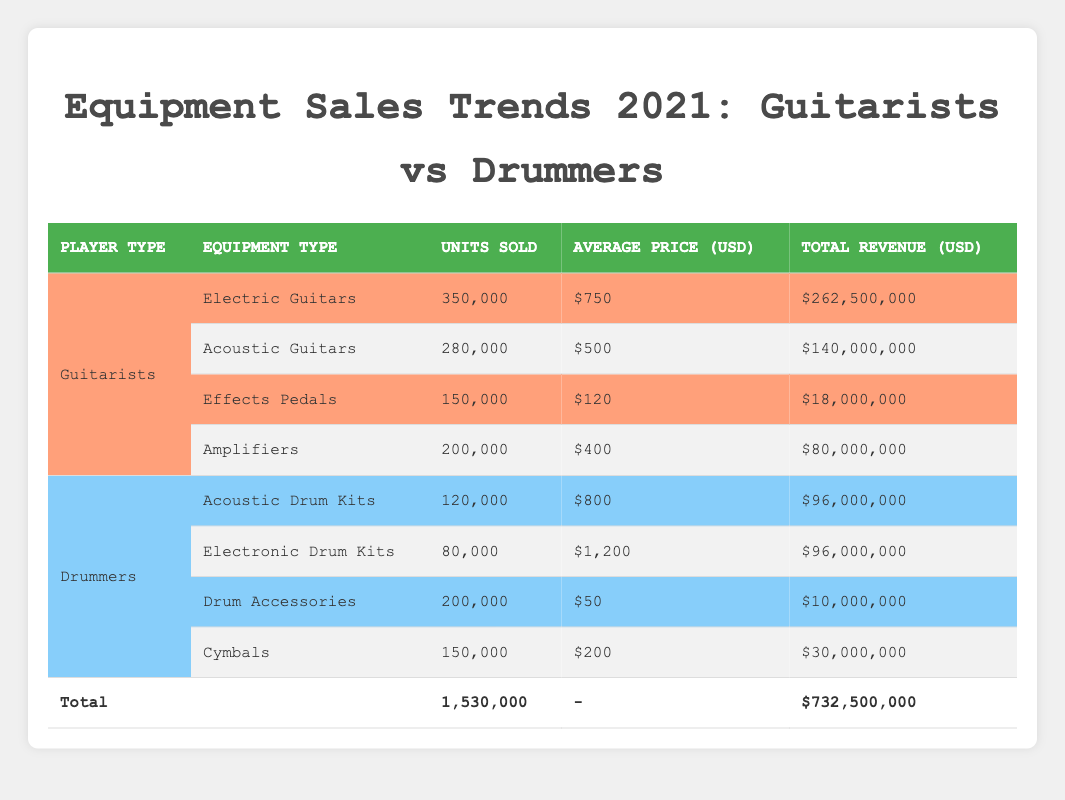What is the total revenue generated from Electric Guitars? The total revenue for Electric Guitars is listed directly in the table under the total revenue column next to Electric Guitars, which is $262,500,000.
Answer: $262,500,000 How many more units of Acoustic Guitars were sold compared to Acoustic Drum Kits? From the table, Acoustic Guitars sold 280,000 units, while Acoustic Drum Kits sold 120,000 units. The difference is 280,000 - 120,000 = 160,000 units.
Answer: 160,000 Is the average price of Electronic Drum Kits higher than that of Amplifiers? The average price for Electronic Drum Kits is $1,200 while the average price for Amplifiers is $400. Since $1,200 > $400, the answer is yes.
Answer: Yes What is the total number of units sold for all Drum accessories? Drum Accessories sold 200,000 units, and there are no other categories under this label in the table. Therefore, the total is simply 200,000 units.
Answer: 200,000 What percentage of the total revenue is generated by Guitarists' equipment? The total revenue for Guitarists is $262,500,000 + $140,000,000 + $18,000,000 + $80,000,000 = $500,500,000. The overall total revenue from both Guitarists and Drummers is $732,500,000. The percentage is (500,500,000 / 732,500,000) * 100, which is approximately 68.3%.
Answer: 68.3% How many units were sold in total for Drummers' equipment? By adding the units sold for each type of Drummers' equipment: 120,000 (Acoustic Drum Kits) + 80,000 (Electronic Drum Kits) + 200,000 (Drum Accessories) + 150,000 (Cymbals) gives a total of 550,000 units sold.
Answer: 550,000 Which category of Guitarists’ equipment sold the highest revenue? The highest revenue among Guitarists' equipment is from Electric Guitars, which generated $262,500,000 in revenue as seen in the table.
Answer: Electric Guitars Are there more units sold in total for Guitarists than for Drummers? Total units for Guitarists are 350,000 (Electric Guitars) + 280,000 (Acoustic Guitars) + 150,000 (Effects Pedals) + 200,000 (Amplifiers) = 980,000. For Drummers, it's 120,000 (Acoustic Drum Kits) + 80,000 (Electronic Drum Kits) + 200,000 (Drum Accessories) + 150,000 (Cymbals) = 550,000. Since 980,000 > 550,000, the answer is yes.
Answer: Yes 